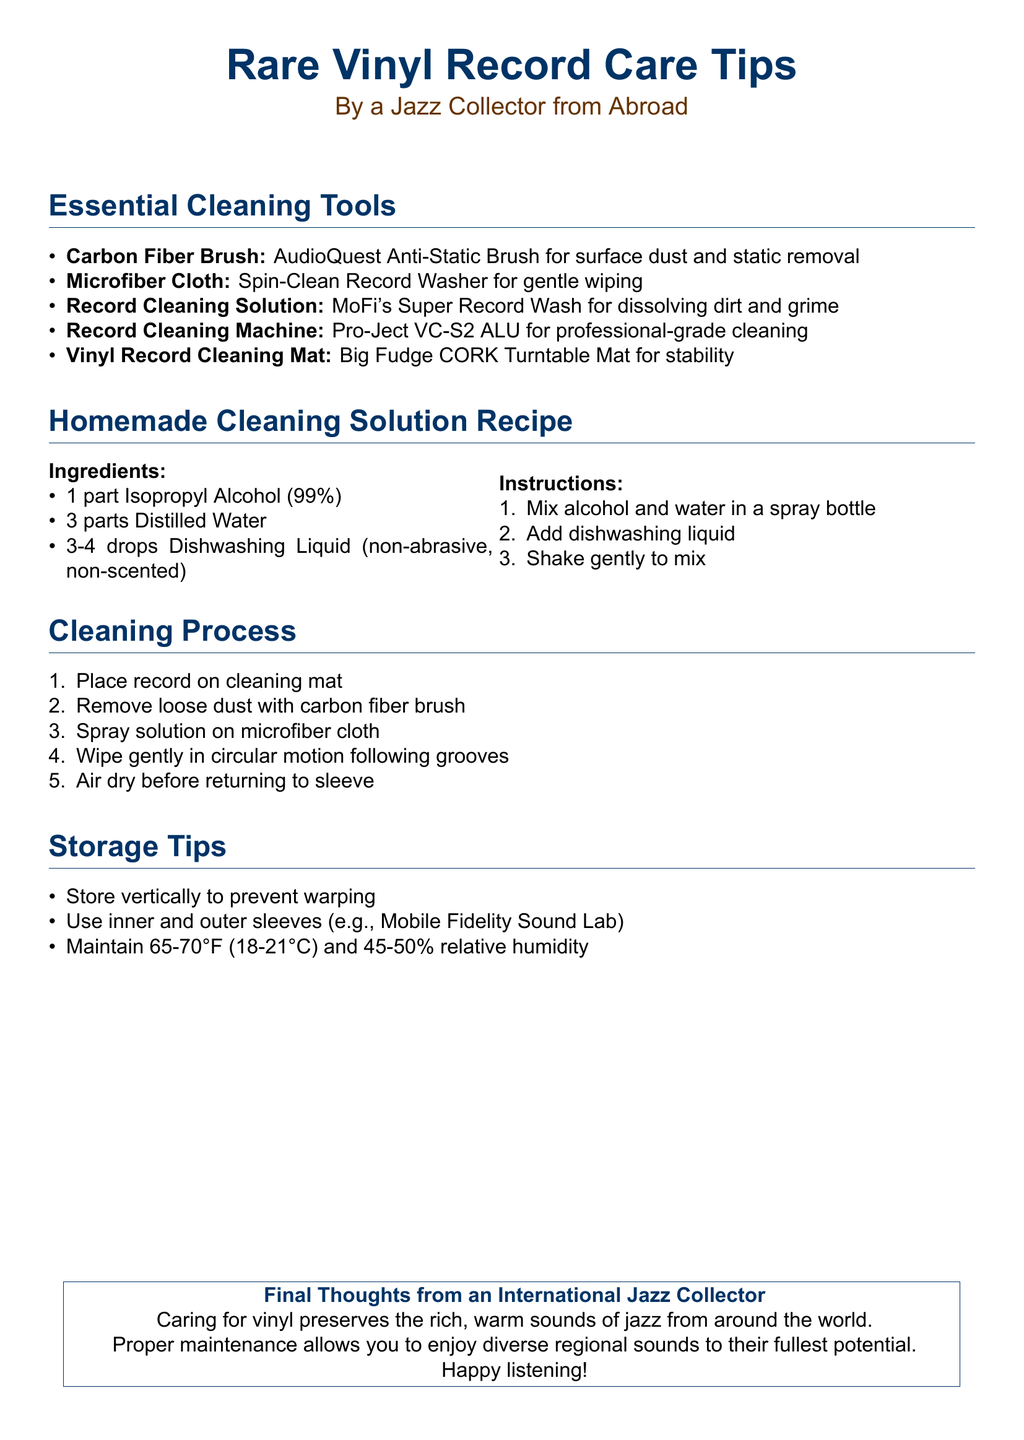what is the main topic of the document? The main topic is Rare Vinyl Record Care Tips, focusing on maintaining and cleaning vinyl records.
Answer: Rare Vinyl Record Care Tips how many parts of isopropyl alcohol are required in the cleaning solution? The recipe for the cleaning solution specifies 1 part Isopropyl Alcohol (99%).
Answer: 1 part which tool is recommended for removing surface dust? The essential cleaning tool for removing surface dust is the Carbon Fiber Brush.
Answer: Carbon Fiber Brush what temperature range is suggested for storing records? The storage tips indicate maintaining a temperature of 65-70°F (18-21°C).
Answer: 65-70°F how should records be stored to prevent warping? The document suggests storing records vertically to prevent warping.
Answer: Vertically what type of dishwashing liquid is recommended in the cleaning solution? The cleaning solution calls for non-abrasive, non-scented dishwashing liquid.
Answer: non-abrasive, non-scented what is the purpose of the Pro-Ject VC-S2 ALU? The Pro-Ject VC-S2 ALU is used for professional-grade cleaning of records.
Answer: professional-grade cleaning which step follows removing loose dust with the carbon fiber brush? After removing loose dust, the next step is to spray solution on the microfiber cloth.
Answer: spray solution on microfiber cloth what is the final thought emphasized by the international jazz collector? The final thought emphasizes that caring for vinyl preserves the rich, warm sounds of jazz.
Answer: preserves the rich, warm sounds of jazz 